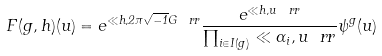<formula> <loc_0><loc_0><loc_500><loc_500>F ( g , h ) ( u ) = e ^ { \ll h , 2 \pi \sqrt { - 1 } G \ r r } \frac { e ^ { \ll h , u \ r r } } { \prod _ { i \in I ( g ) } \ll \alpha _ { i } , u \ r r } \psi ^ { g } ( u )</formula> 